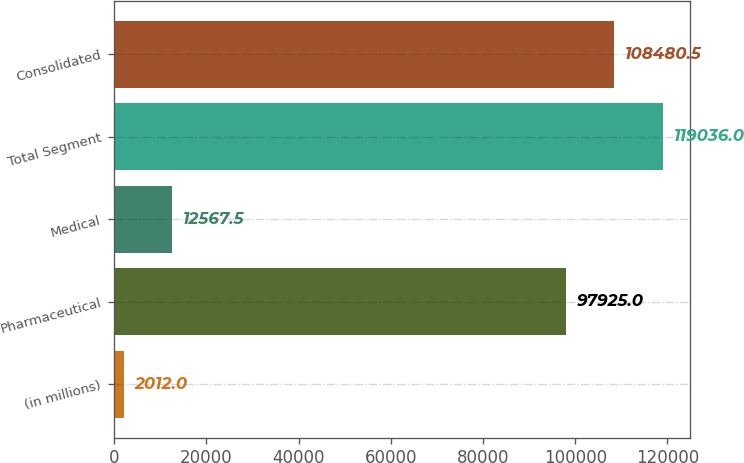Convert chart to OTSL. <chart><loc_0><loc_0><loc_500><loc_500><bar_chart><fcel>(in millions)<fcel>Pharmaceutical<fcel>Medical<fcel>Total Segment<fcel>Consolidated<nl><fcel>2012<fcel>97925<fcel>12567.5<fcel>119036<fcel>108480<nl></chart> 